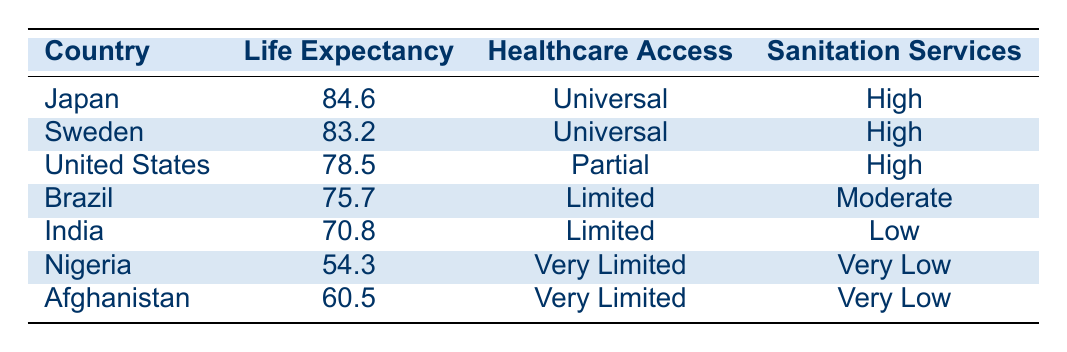What is the life expectancy of Japan? By looking at the row for Japan in the table, it shows that the life expectancy is 84.6 years.
Answer: 84.6 Which country has the lowest life expectancy? The table lists Nigeria with the lowest life expectancy of 54.3 years.
Answer: Nigeria Is the healthcare access in Sweden universal? The table states that Sweden has "Universal" healthcare access, confirming this as true.
Answer: Yes What is the average life expectancy of countries with "Limited" healthcare access? The countries with "Limited" healthcare access are Brazil (75.7), India (70.8). To find the average: (75.7 + 70.8) / 2 = 73.25.
Answer: 73.25 How many countries have "High" sanitation services and what is their average life expectancy? The countries with "High" sanitation services are Japan (84.6), Sweden (83.2), and the United States (78.5). There are 3 countries. The average life expectancy is calculated as (84.6 + 83.2 + 78.5) / 3 = 82.1.
Answer: 82.1 Is there any country listed that has both "Very Limited" healthcare access and "Very Low" sanitation services? Yes, both Nigeria and Afghanistan have "Very Limited" healthcare access and "Very Low" sanitation services according to the table.
Answer: Yes What is the difference in life expectancy between Japan and the United States? The life expectancy in Japan is 84.6 years and in the United States, it is 78.5 years. The difference is calculated as 84.6 - 78.5 = 6.1 years.
Answer: 6.1 Are there more countries with universal healthcare access or very limited healthcare access? There are 2 countries (Japan and Sweden) with "Universal" healthcare access and 2 countries (Nigeria and Afghanistan) with "Very Limited" healthcare access. Therefore, the numbers are equal.
Answer: Equal How does access to healthcare correlate with life expectancy based on the table? Observing the data, countries with "Universal" access (Japan and Sweden) show the highest life expectancies, followed by those with "Partial" and "Limited" access, indicating a correlation where increased healthcare access corresponds to higher life expectancy.
Answer: Higher access correlates with higher life expectancy 